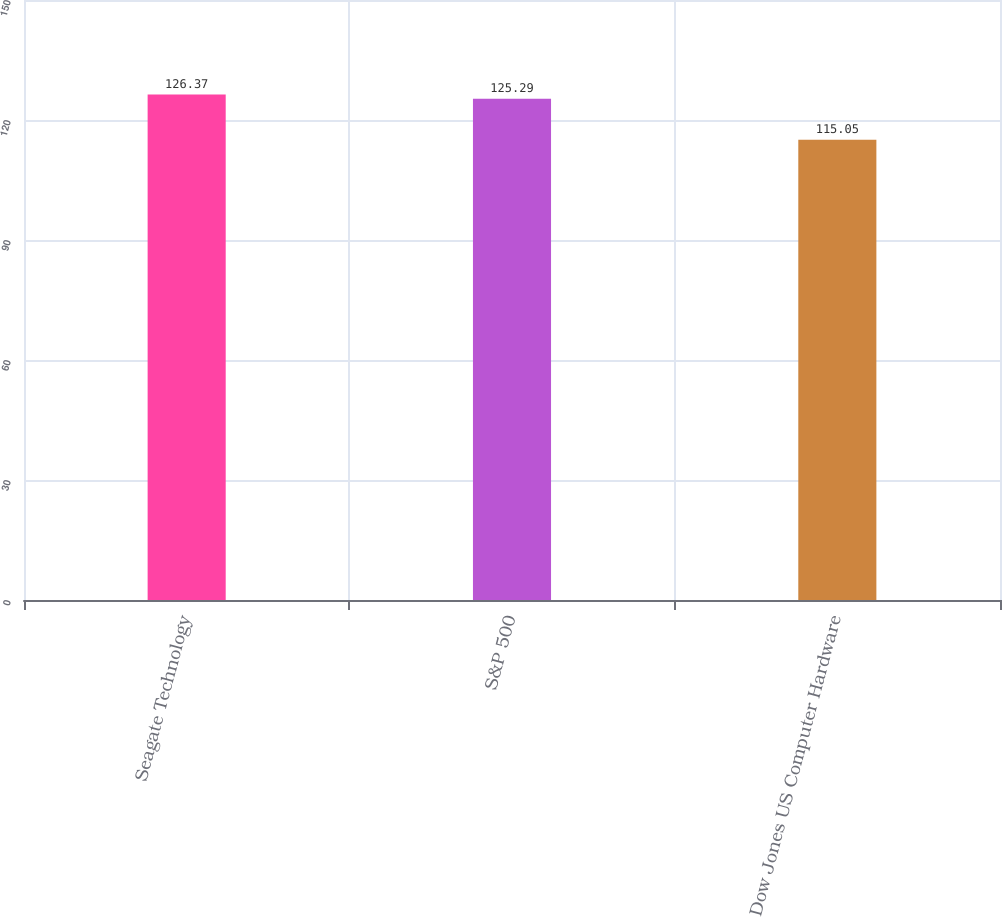Convert chart. <chart><loc_0><loc_0><loc_500><loc_500><bar_chart><fcel>Seagate Technology<fcel>S&P 500<fcel>Dow Jones US Computer Hardware<nl><fcel>126.37<fcel>125.29<fcel>115.05<nl></chart> 